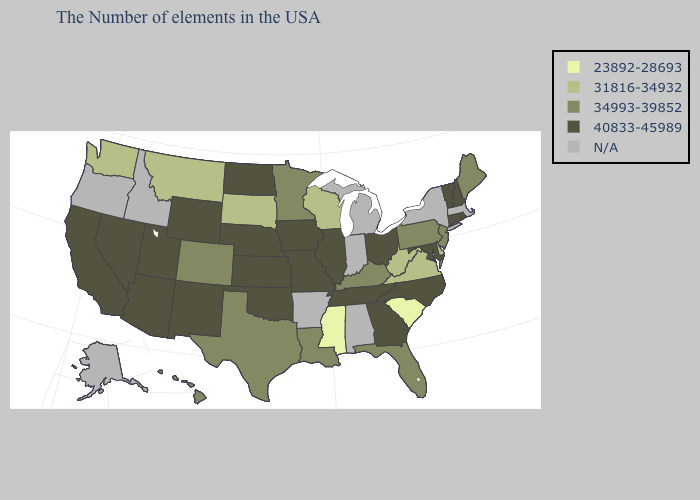What is the highest value in the USA?
Give a very brief answer. 40833-45989. Name the states that have a value in the range 40833-45989?
Be succinct. Rhode Island, New Hampshire, Vermont, Connecticut, Maryland, North Carolina, Ohio, Georgia, Tennessee, Illinois, Missouri, Iowa, Kansas, Nebraska, Oklahoma, North Dakota, Wyoming, New Mexico, Utah, Arizona, Nevada, California. What is the value of Indiana?
Quick response, please. N/A. Name the states that have a value in the range N/A?
Write a very short answer. Massachusetts, New York, Michigan, Indiana, Alabama, Arkansas, Idaho, Oregon, Alaska. Does the first symbol in the legend represent the smallest category?
Write a very short answer. Yes. Name the states that have a value in the range 40833-45989?
Be succinct. Rhode Island, New Hampshire, Vermont, Connecticut, Maryland, North Carolina, Ohio, Georgia, Tennessee, Illinois, Missouri, Iowa, Kansas, Nebraska, Oklahoma, North Dakota, Wyoming, New Mexico, Utah, Arizona, Nevada, California. Which states have the lowest value in the West?
Keep it brief. Montana, Washington. What is the value of Hawaii?
Concise answer only. 34993-39852. Which states have the lowest value in the USA?
Answer briefly. South Carolina, Mississippi. Name the states that have a value in the range 23892-28693?
Be succinct. South Carolina, Mississippi. What is the value of Illinois?
Be succinct. 40833-45989. What is the value of Michigan?
Short answer required. N/A. Does Rhode Island have the lowest value in the Northeast?
Give a very brief answer. No. Name the states that have a value in the range 34993-39852?
Be succinct. Maine, New Jersey, Pennsylvania, Florida, Kentucky, Louisiana, Minnesota, Texas, Colorado, Hawaii. Which states hav the highest value in the West?
Quick response, please. Wyoming, New Mexico, Utah, Arizona, Nevada, California. 